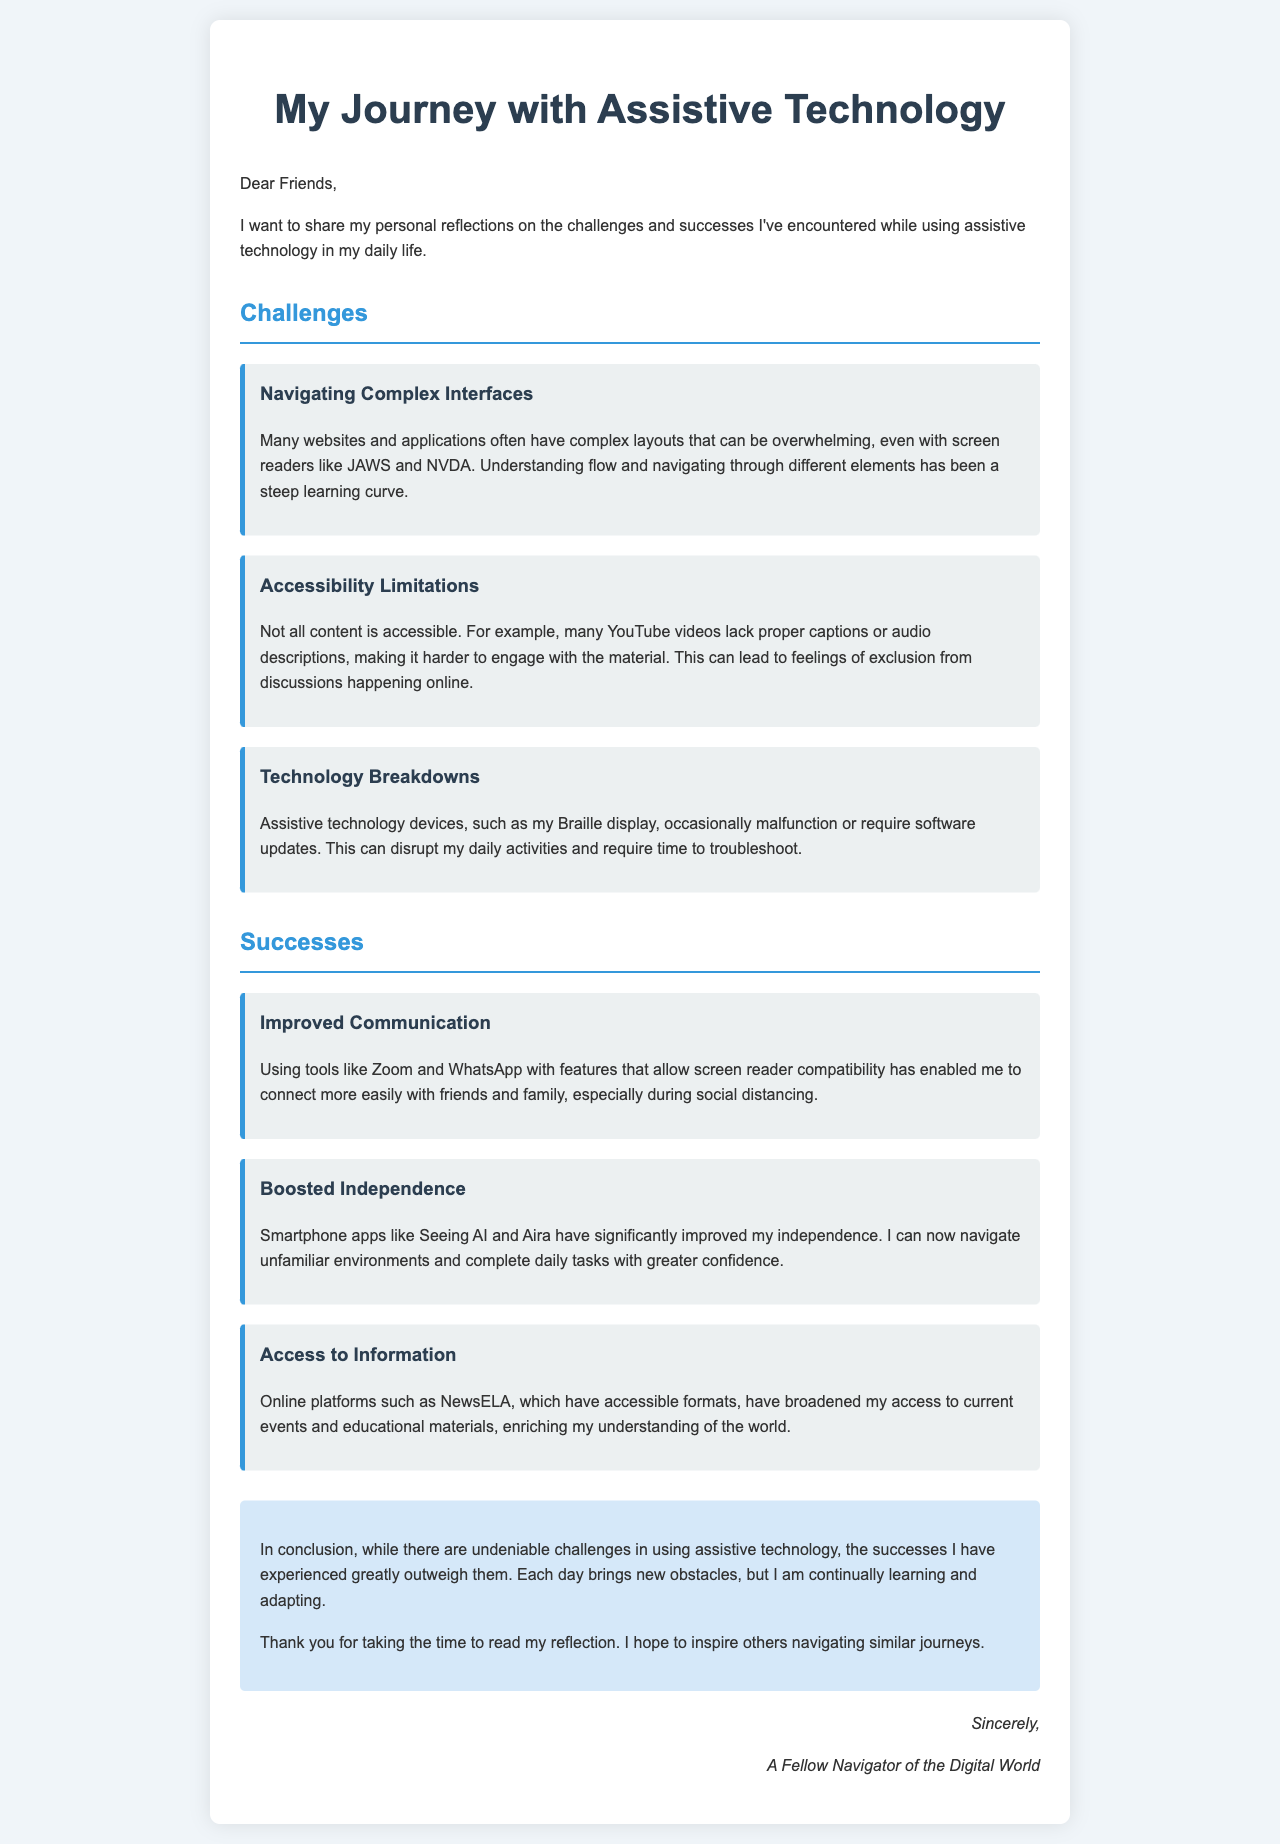What is the title of the letter? The title of the letter is stated at the top of the document.
Answer: My Journey with Assistive Technology What is one of the challenges mentioned? The letter lists several challenges faced while using assistive technology.
Answer: Navigating Complex Interfaces What technology is mentioned for improved communication? The author refers to tools that enhance communication in the letter.
Answer: Zoom and WhatsApp How has the author improved their independence? The letter describes specific smartphone apps that contributed to the author's independence.
Answer: Seeing AI and Aira Which online platform has broadened access to information? The document indicates a specific platform that offers accessible formats for information.
Answer: NewsELA What is a limitation mentioned regarding YouTube videos? The letter highlights a specific issue related to YouTube content accessibility.
Answer: Lack of proper captions or audio descriptions What theme is emphasized in the conclusion? The conclusion provides a summary of the author's overall feelings regarding their experiences.
Answer: Successes outweigh challenges How does the author address the readers? The author's style of addressing the audience is indicated at the beginning of the document.
Answer: Dear Friends 